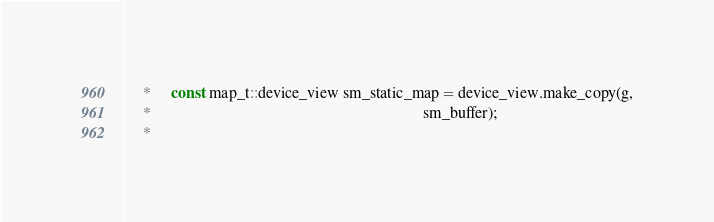<code> <loc_0><loc_0><loc_500><loc_500><_Cuda_>     *     const map_t::device_view sm_static_map = device_view.make_copy(g,
     *                                                                    sm_buffer);
     *</code> 